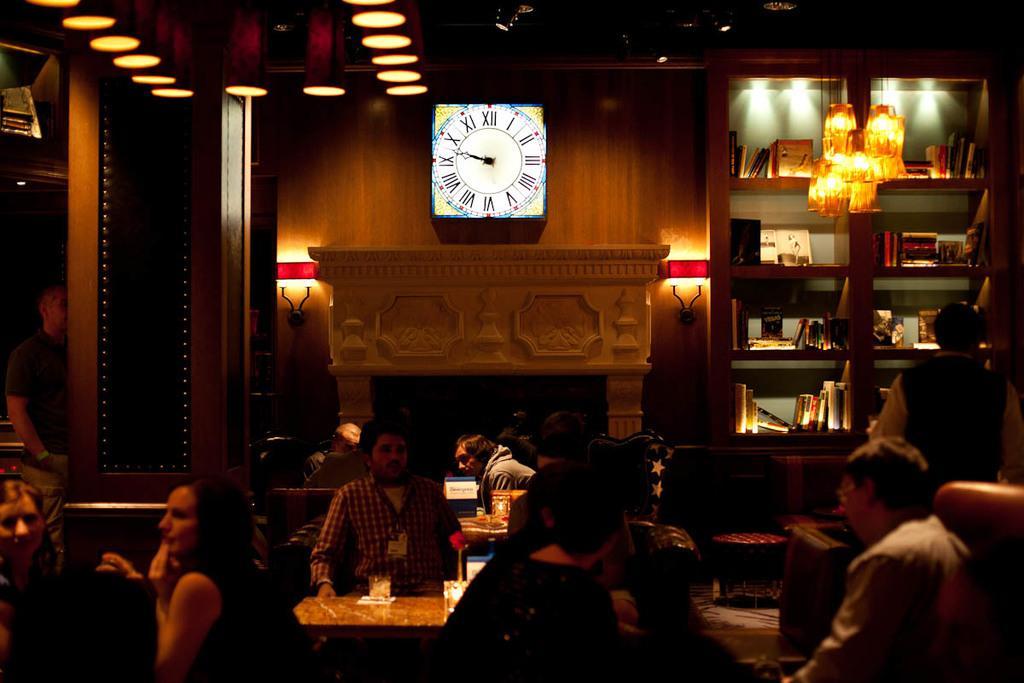Can you describe this image briefly? In this picture I can observe some people sitting in the chairs in front of their respective tables. There are men and women in this picture. I can observe a wall clock on the wall. On the right side there is a chandelier. I can observe bookshelf in which some books are placed. In the background there is a wall. 